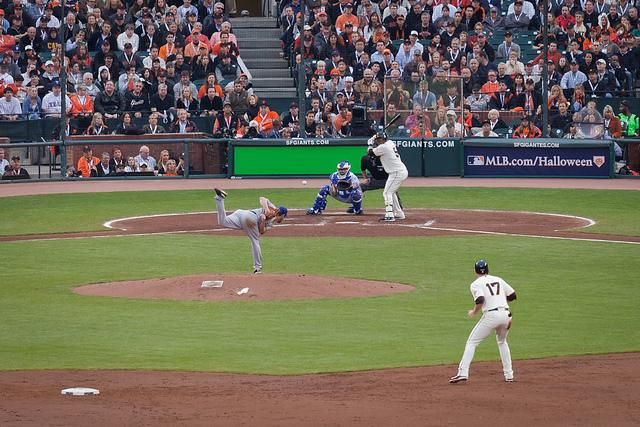What is the man on one leg doing? pitching 